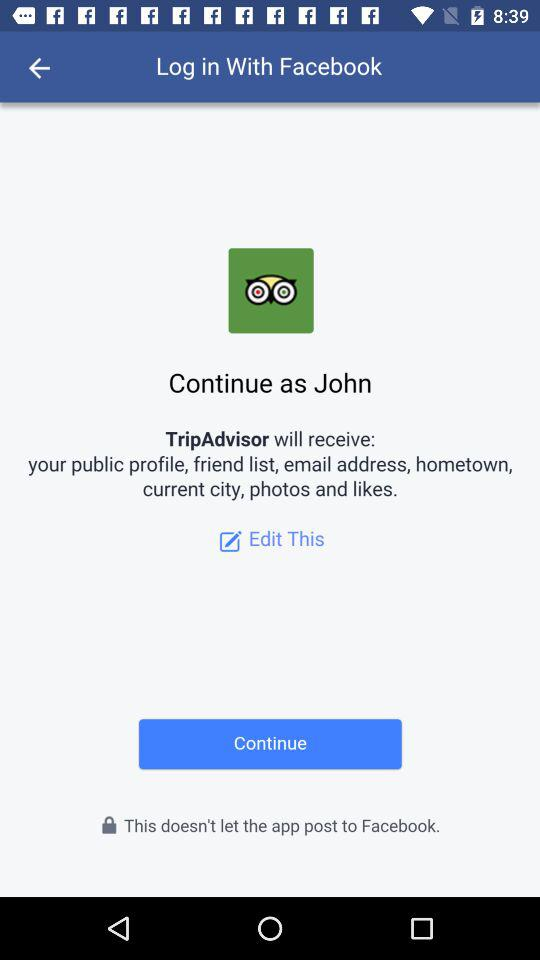How can we log in? You can log in with "Facebook". 